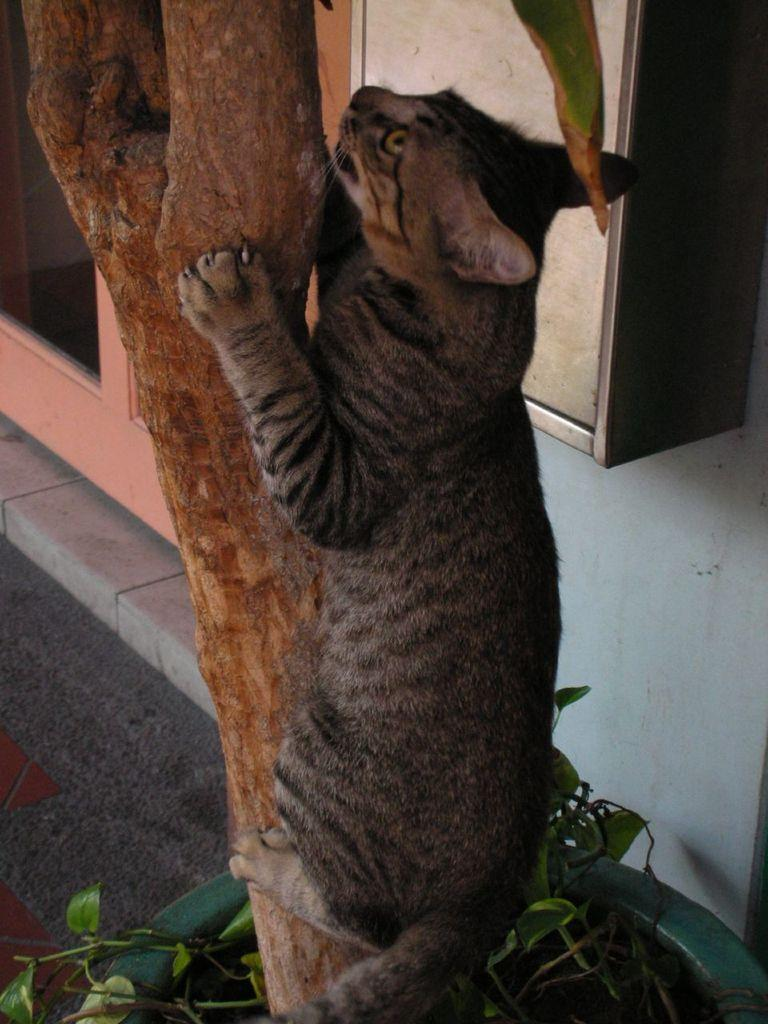What type of animal is in the image? There is a cat in the image. What is the cat doing in the image? The cat is climbing a tree. What other objects can be seen in the image? There is a plant, a carpet on the floor, a wall, glass, and a box in the background of the image. What is the reason for the cat's self-awareness in the image? There is no indication of the cat's self-awareness or any reason for it in the image. 